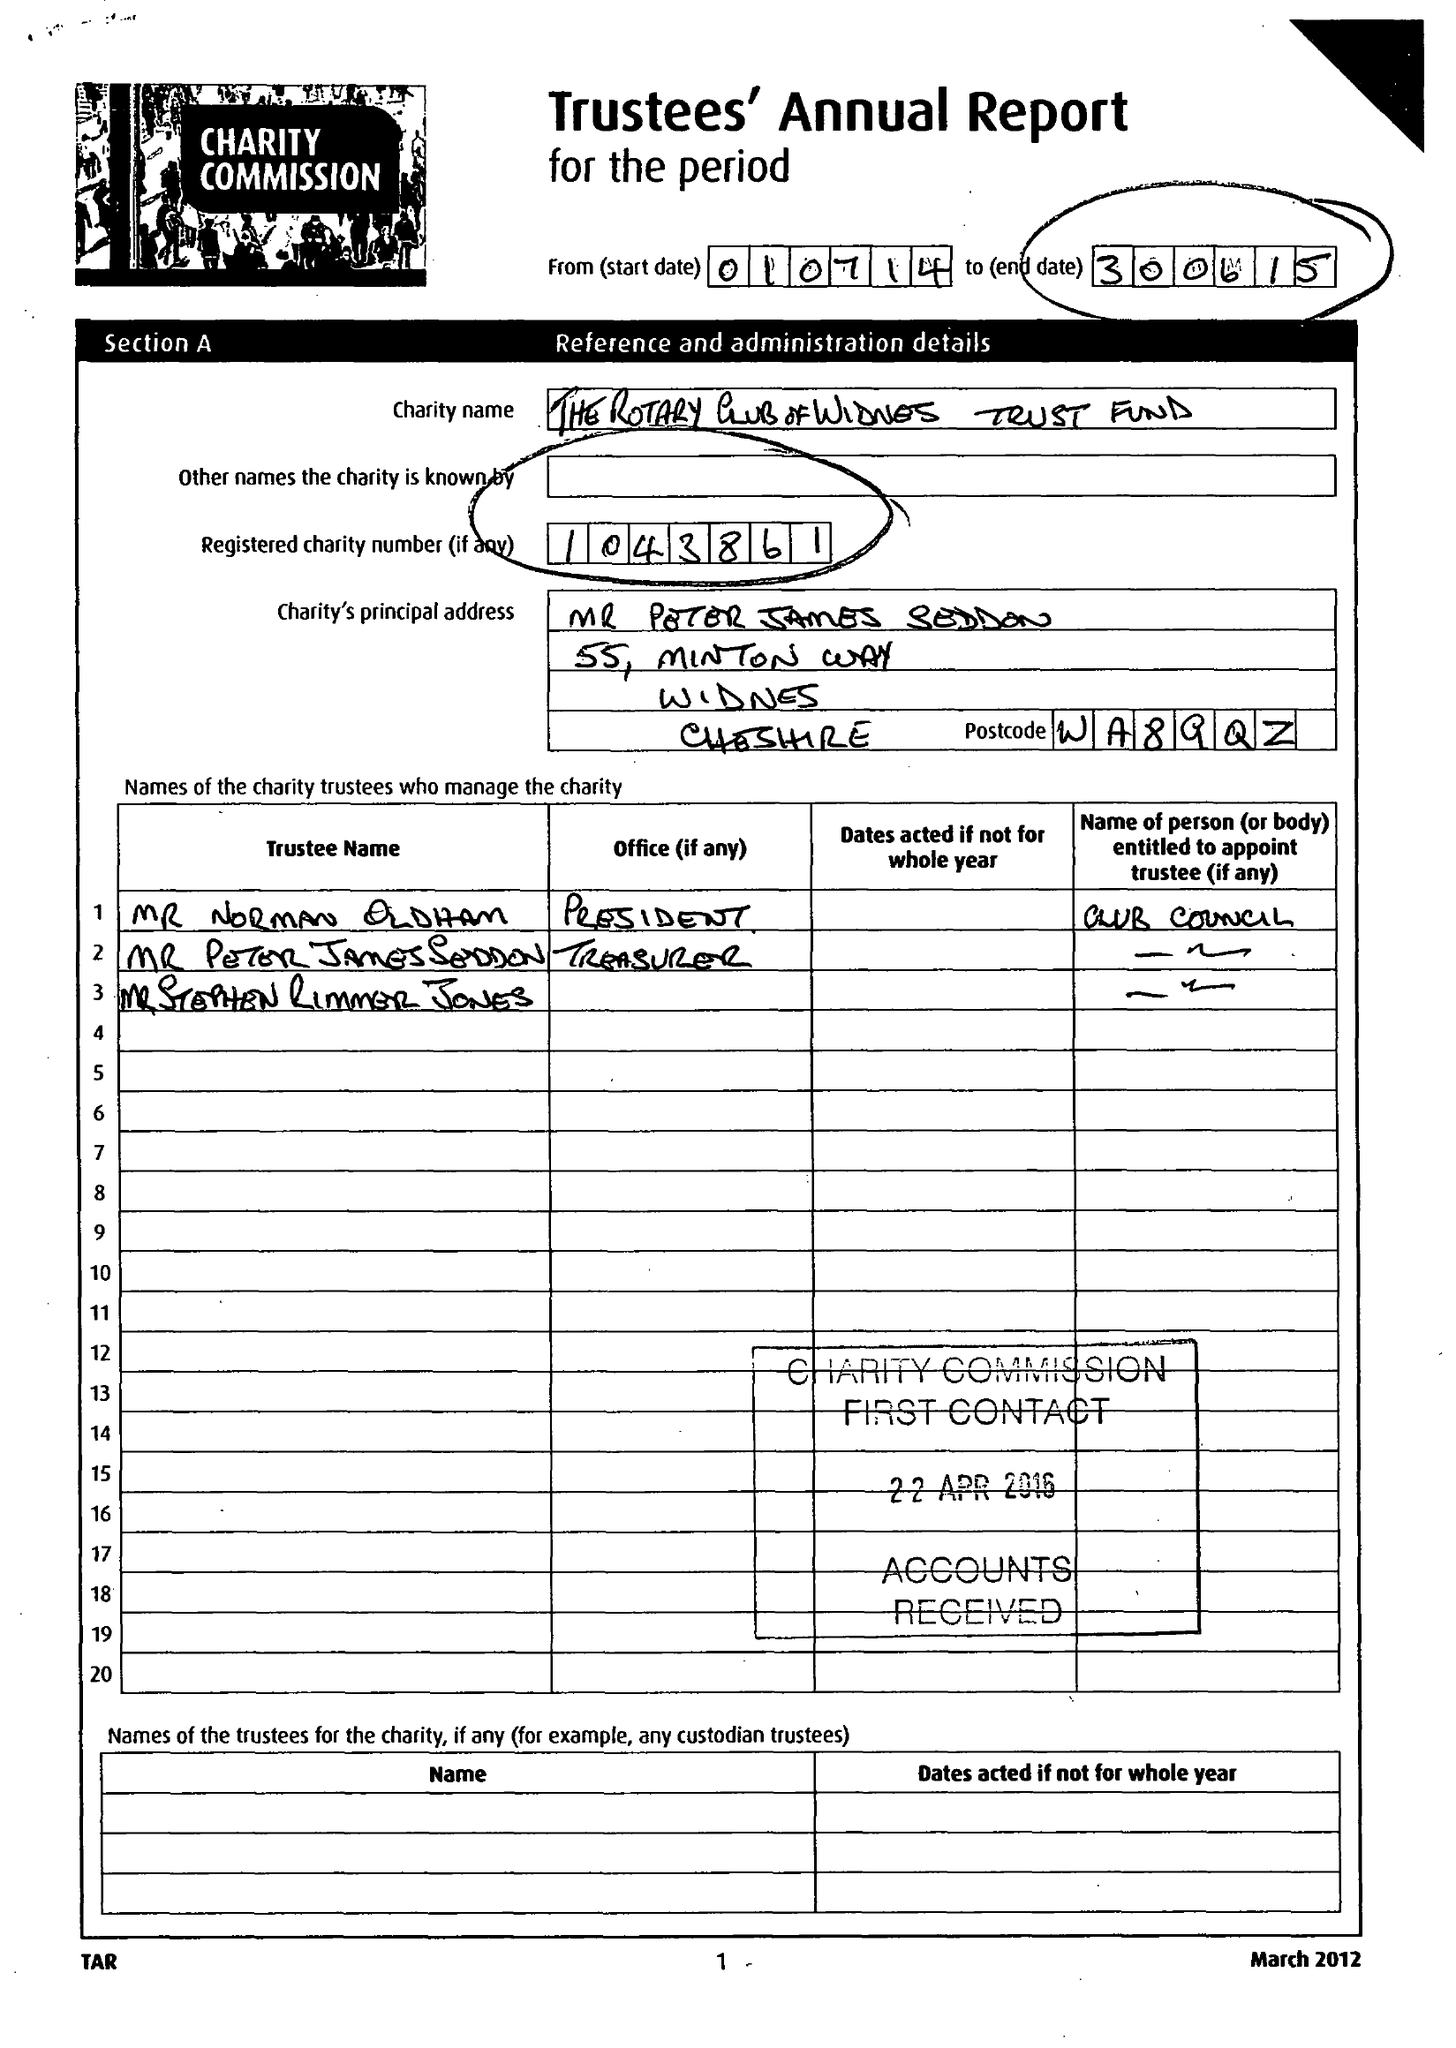What is the value for the address__post_town?
Answer the question using a single word or phrase. WIDNES 